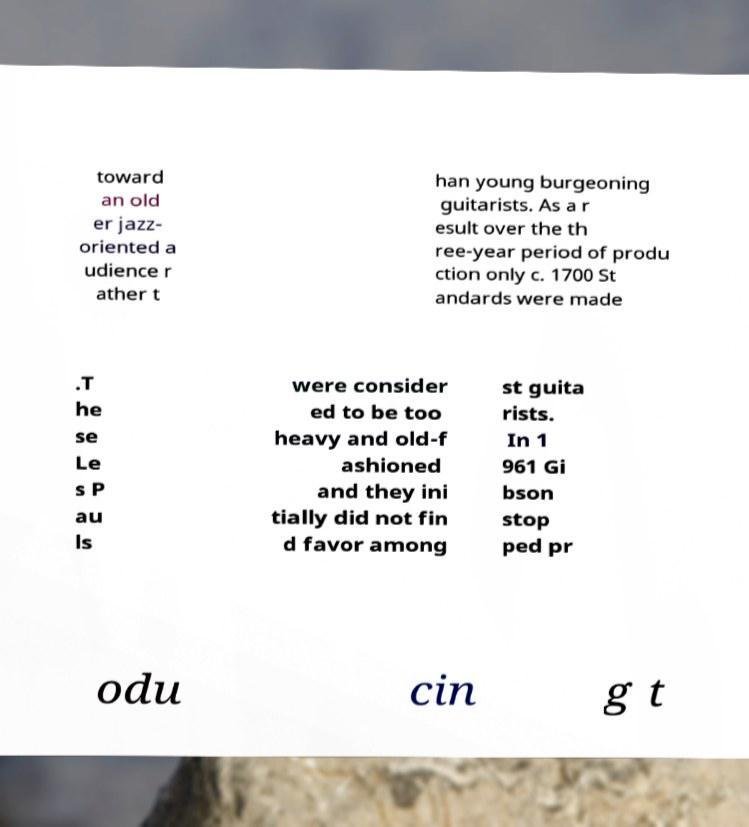I need the written content from this picture converted into text. Can you do that? toward an old er jazz- oriented a udience r ather t han young burgeoning guitarists. As a r esult over the th ree-year period of produ ction only c. 1700 St andards were made .T he se Le s P au ls were consider ed to be too heavy and old-f ashioned and they ini tially did not fin d favor among st guita rists. In 1 961 Gi bson stop ped pr odu cin g t 